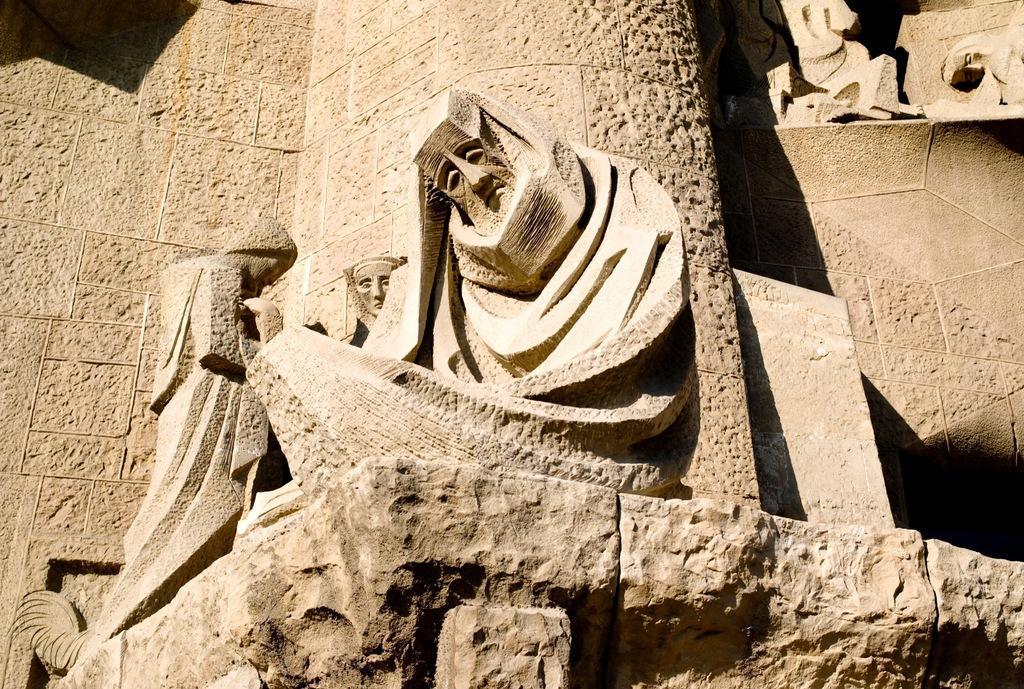In one or two sentences, can you explain what this image depicts? In the picture I can see some sculptures which are made of stone and in the background there is stone wall. 